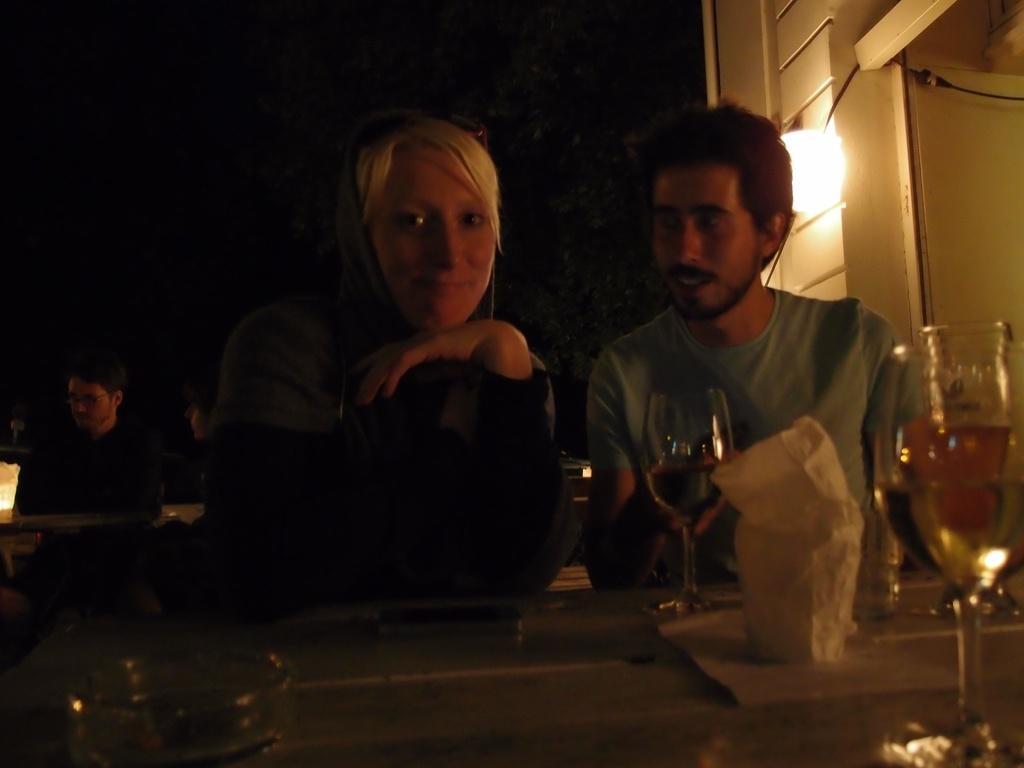Describe this image in one or two sentences. This picture is clicked inside. In the foreground there is a table on the top of which glasses of drinks and some other items are placed. On the right there is a man wearing t-shirt and sitting on the chair. On the left there is a woman, smiling and sitting on the chair. In the background we can see the lights, cable, wall and some persons sitting on the chairs. 